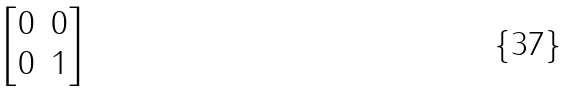Convert formula to latex. <formula><loc_0><loc_0><loc_500><loc_500>\begin{bmatrix} 0 & 0 \\ 0 & 1 \\ \end{bmatrix}</formula> 